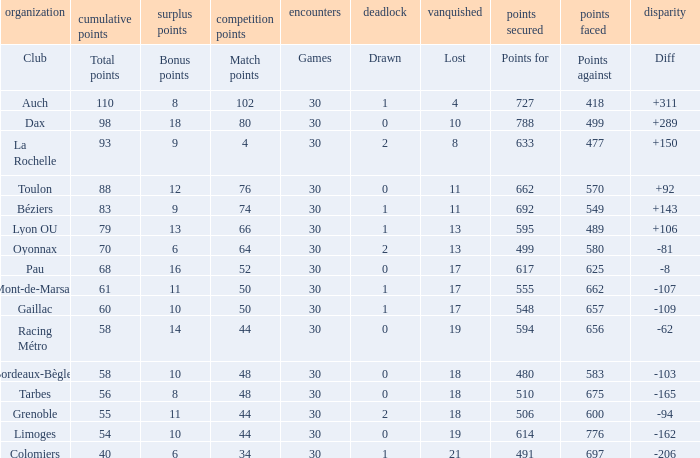How many bonus points did the Colomiers earn? 6.0. 